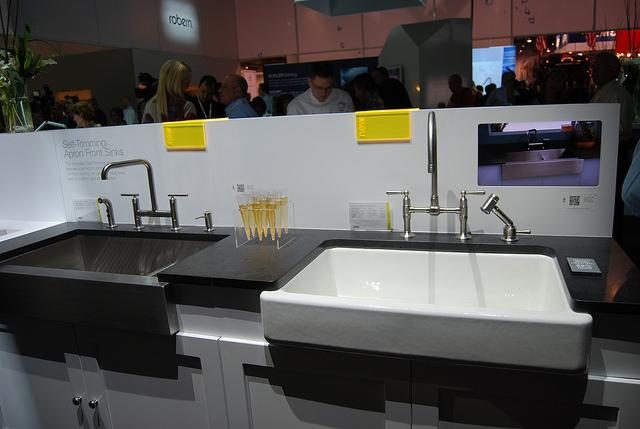What is found in the room? sink 